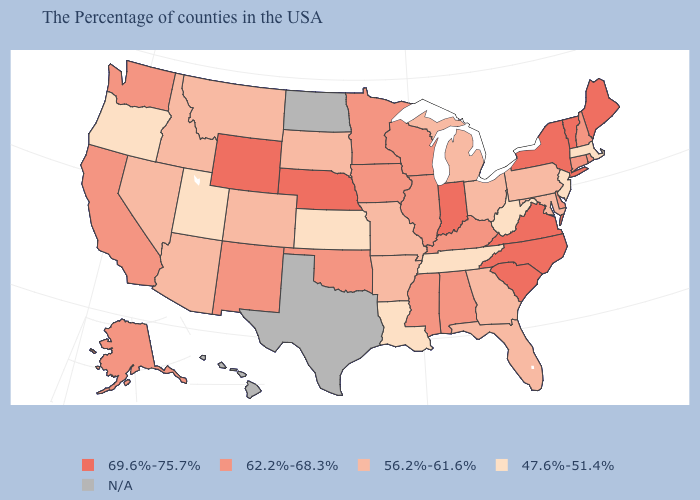Name the states that have a value in the range 56.2%-61.6%?
Short answer required. Maryland, Pennsylvania, Ohio, Florida, Georgia, Michigan, Missouri, Arkansas, South Dakota, Colorado, Montana, Arizona, Idaho, Nevada. What is the value of Utah?
Concise answer only. 47.6%-51.4%. Name the states that have a value in the range 56.2%-61.6%?
Be succinct. Maryland, Pennsylvania, Ohio, Florida, Georgia, Michigan, Missouri, Arkansas, South Dakota, Colorado, Montana, Arizona, Idaho, Nevada. Does the map have missing data?
Quick response, please. Yes. What is the value of Washington?
Write a very short answer. 62.2%-68.3%. Name the states that have a value in the range N/A?
Keep it brief. Texas, North Dakota, Hawaii. Name the states that have a value in the range 47.6%-51.4%?
Answer briefly. Massachusetts, New Jersey, West Virginia, Tennessee, Louisiana, Kansas, Utah, Oregon. What is the highest value in the West ?
Concise answer only. 69.6%-75.7%. What is the lowest value in the MidWest?
Be succinct. 47.6%-51.4%. Among the states that border Maine , which have the lowest value?
Write a very short answer. New Hampshire. What is the highest value in the MidWest ?
Give a very brief answer. 69.6%-75.7%. What is the value of Missouri?
Write a very short answer. 56.2%-61.6%. 